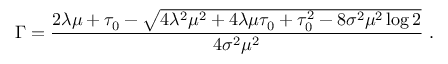Convert formula to latex. <formula><loc_0><loc_0><loc_500><loc_500>\Gamma = { \frac { 2 \lambda \mu + \tau _ { 0 } - \sqrt { 4 \lambda ^ { 2 } \mu ^ { 2 } + 4 \lambda \mu \tau _ { 0 } + \tau _ { 0 } ^ { 2 } - 8 \sigma ^ { 2 } \mu ^ { 2 } \log 2 } } { 4 \sigma ^ { 2 } \mu ^ { 2 } } } \, .</formula> 